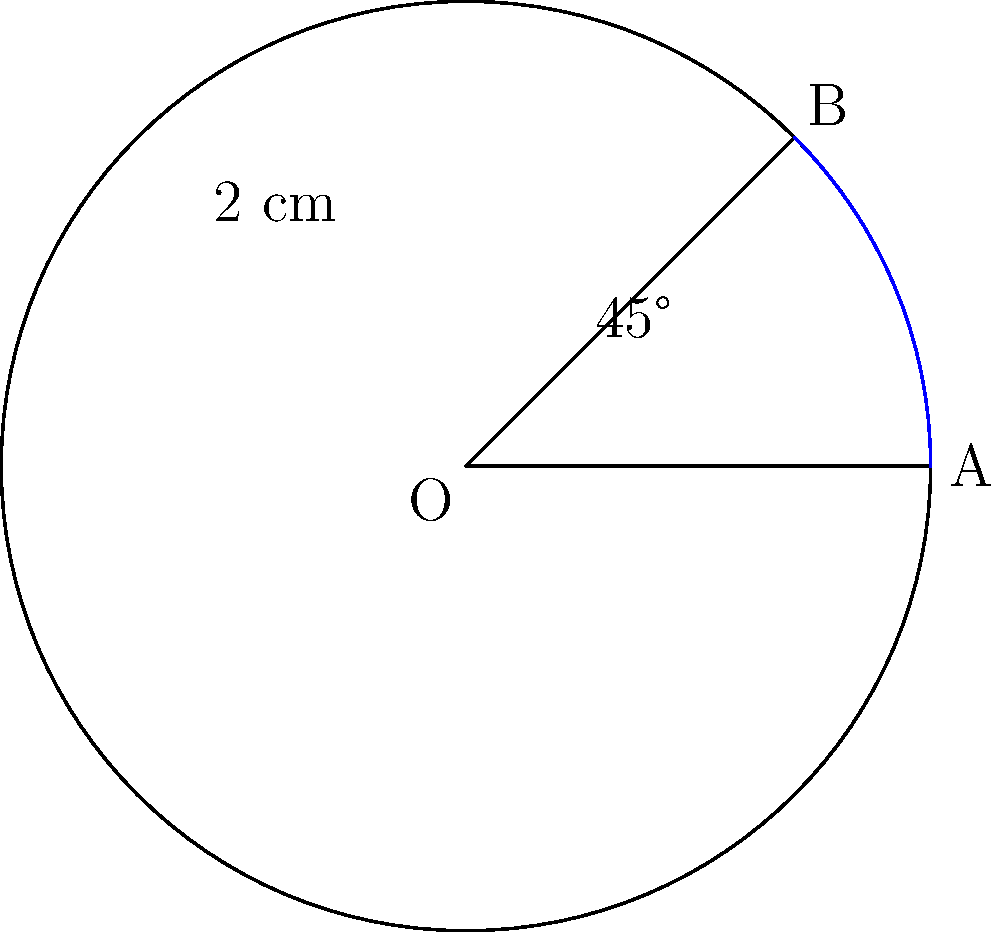As a digital marketing specialist for a family tree platform, you're creating a circular infographic to showcase user growth. The infographic is shaped like a circular sector with a radius of 2 cm and a central angle of 45°. Calculate the area of this circular sector to determine the space available for displaying user statistics. To calculate the area of a circular sector, we'll follow these steps:

1) The formula for the area of a circular sector is:
   
   $$ A = \frac{1}{2} r^2 \theta $$

   Where $A$ is the area, $r$ is the radius, and $\theta$ is the central angle in radians.

2) We're given the radius $r = 2$ cm and the central angle of 45°. We need to convert 45° to radians:
   
   $$ 45° = 45 \times \frac{\pi}{180} = \frac{\pi}{4} \text{ radians} $$

3) Now we can substitute these values into our formula:
   
   $$ A = \frac{1}{2} \times 2^2 \times \frac{\pi}{4} $$

4) Simplify:
   
   $$ A = \frac{1}{2} \times 4 \times \frac{\pi}{4} = \frac{\pi}{2} \text{ cm}^2 $$

Therefore, the area of the circular sector is $\frac{\pi}{2}$ square centimeters.
Answer: $\frac{\pi}{2}$ cm² 